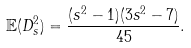Convert formula to latex. <formula><loc_0><loc_0><loc_500><loc_500>\mathbb { E } ( D _ { s } ^ { 2 } ) = \frac { ( s ^ { 2 } - 1 ) ( 3 s ^ { 2 } - 7 ) } { 4 5 } .</formula> 